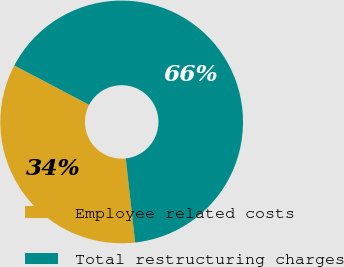Convert chart to OTSL. <chart><loc_0><loc_0><loc_500><loc_500><pie_chart><fcel>Employee related costs<fcel>Total restructuring charges<nl><fcel>34.48%<fcel>65.52%<nl></chart> 